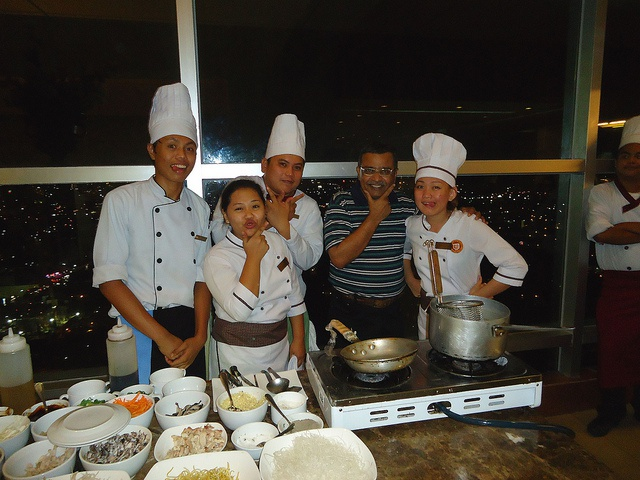Describe the objects in this image and their specific colors. I can see people in black, darkgray, and maroon tones, people in black, darkgray, and maroon tones, people in black, darkgray, brown, and maroon tones, people in black, maroon, and gray tones, and people in black, gray, and maroon tones in this image. 